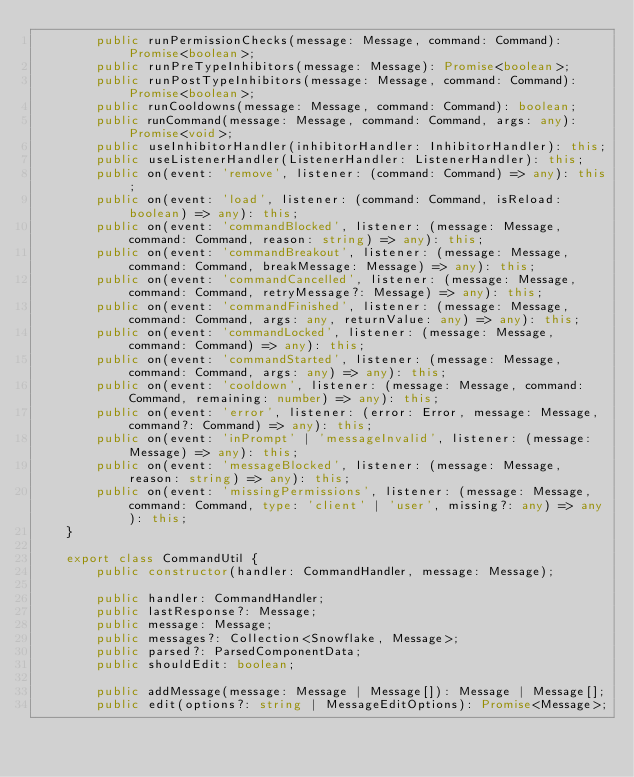<code> <loc_0><loc_0><loc_500><loc_500><_TypeScript_>        public runPermissionChecks(message: Message, command: Command): Promise<boolean>;
        public runPreTypeInhibitors(message: Message): Promise<boolean>;
        public runPostTypeInhibitors(message: Message, command: Command): Promise<boolean>;
        public runCooldowns(message: Message, command: Command): boolean;
        public runCommand(message: Message, command: Command, args: any): Promise<void>;
        public useInhibitorHandler(inhibitorHandler: InhibitorHandler): this;
        public useListenerHandler(ListenerHandler: ListenerHandler): this;
        public on(event: 'remove', listener: (command: Command) => any): this;
        public on(event: 'load', listener: (command: Command, isReload: boolean) => any): this;
        public on(event: 'commandBlocked', listener: (message: Message, command: Command, reason: string) => any): this;
        public on(event: 'commandBreakout', listener: (message: Message, command: Command, breakMessage: Message) => any): this;
        public on(event: 'commandCancelled', listener: (message: Message, command: Command, retryMessage?: Message) => any): this;
        public on(event: 'commandFinished', listener: (message: Message, command: Command, args: any, returnValue: any) => any): this;
        public on(event: 'commandLocked', listener: (message: Message, command: Command) => any): this;
        public on(event: 'commandStarted', listener: (message: Message, command: Command, args: any) => any): this;
        public on(event: 'cooldown', listener: (message: Message, command: Command, remaining: number) => any): this;
        public on(event: 'error', listener: (error: Error, message: Message, command?: Command) => any): this;
        public on(event: 'inPrompt' | 'messageInvalid', listener: (message: Message) => any): this;
        public on(event: 'messageBlocked', listener: (message: Message, reason: string) => any): this;
        public on(event: 'missingPermissions', listener: (message: Message, command: Command, type: 'client' | 'user', missing?: any) => any): this;
    }

    export class CommandUtil {
        public constructor(handler: CommandHandler, message: Message);

        public handler: CommandHandler;
        public lastResponse?: Message;
        public message: Message;
        public messages?: Collection<Snowflake, Message>;
        public parsed?: ParsedComponentData;
        public shouldEdit: boolean;

        public addMessage(message: Message | Message[]): Message | Message[];
        public edit(options?: string | MessageEditOptions): Promise<Message>;</code> 